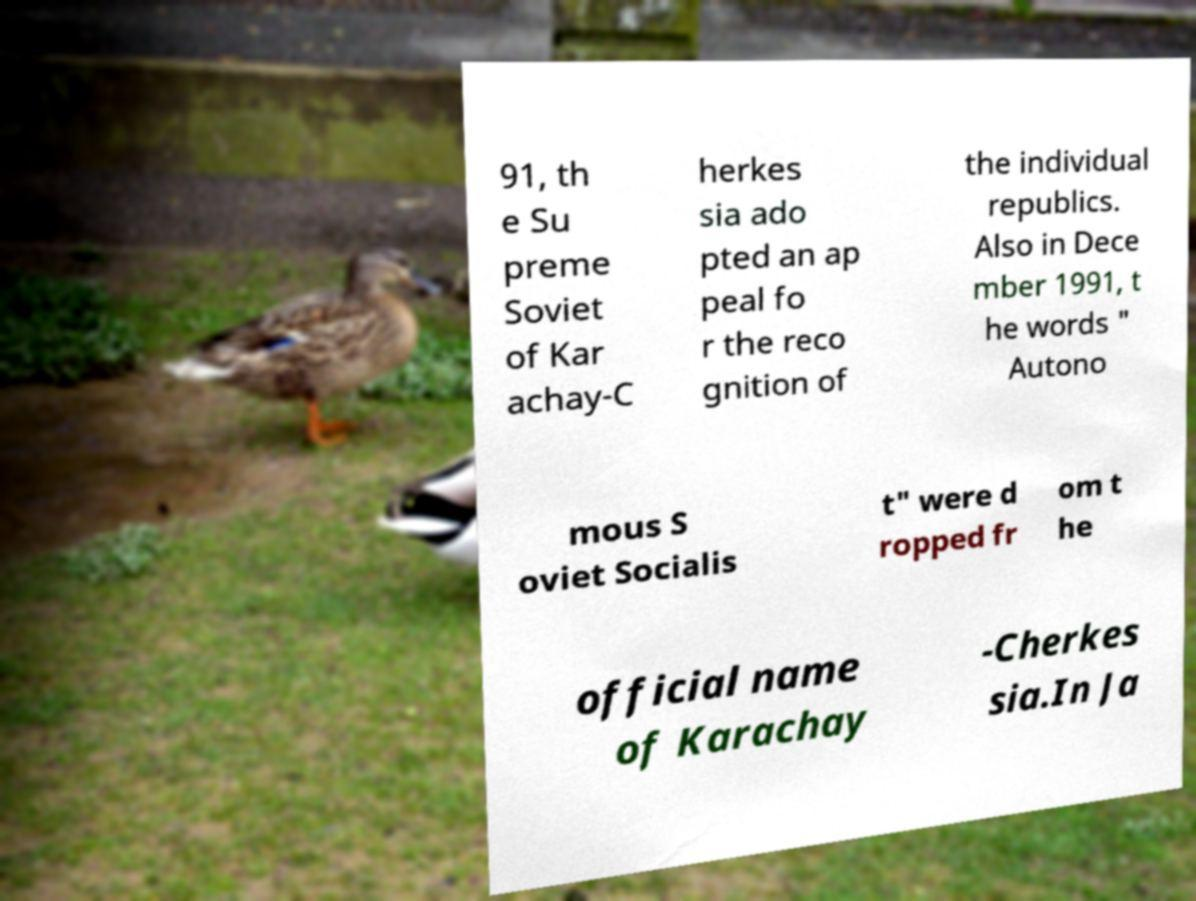What messages or text are displayed in this image? I need them in a readable, typed format. 91, th e Su preme Soviet of Kar achay-C herkes sia ado pted an ap peal fo r the reco gnition of the individual republics. Also in Dece mber 1991, t he words " Autono mous S oviet Socialis t" were d ropped fr om t he official name of Karachay -Cherkes sia.In Ja 